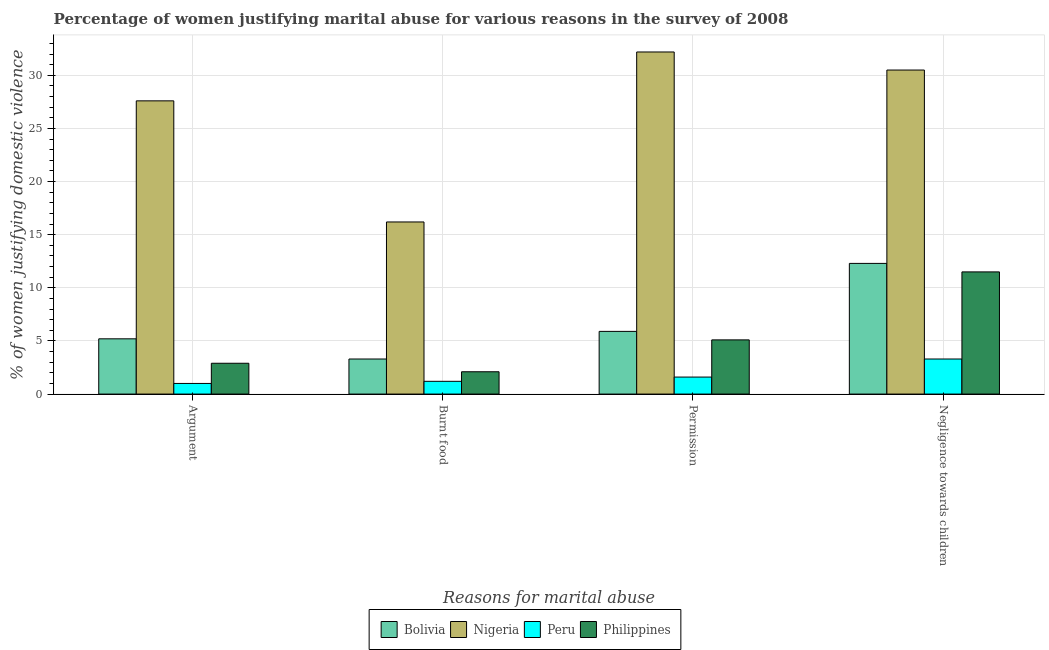How many different coloured bars are there?
Provide a succinct answer. 4. Are the number of bars on each tick of the X-axis equal?
Provide a succinct answer. Yes. How many bars are there on the 3rd tick from the left?
Provide a short and direct response. 4. How many bars are there on the 3rd tick from the right?
Provide a short and direct response. 4. What is the label of the 2nd group of bars from the left?
Offer a terse response. Burnt food. What is the percentage of women justifying abuse for showing negligence towards children in Bolivia?
Keep it short and to the point. 12.3. Across all countries, what is the maximum percentage of women justifying abuse for showing negligence towards children?
Your answer should be very brief. 30.5. In which country was the percentage of women justifying abuse in the case of an argument maximum?
Offer a terse response. Nigeria. What is the total percentage of women justifying abuse in the case of an argument in the graph?
Your response must be concise. 36.7. What is the difference between the percentage of women justifying abuse in the case of an argument in Bolivia and that in Peru?
Give a very brief answer. 4.2. What is the difference between the percentage of women justifying abuse for showing negligence towards children in Peru and the percentage of women justifying abuse for burning food in Nigeria?
Offer a very short reply. -12.9. What is the average percentage of women justifying abuse for burning food per country?
Keep it short and to the point. 5.7. What is the difference between the percentage of women justifying abuse for showing negligence towards children and percentage of women justifying abuse in the case of an argument in Bolivia?
Offer a terse response. 7.1. In how many countries, is the percentage of women justifying abuse for showing negligence towards children greater than 31 %?
Offer a terse response. 0. What is the ratio of the percentage of women justifying abuse for going without permission in Nigeria to that in Bolivia?
Your response must be concise. 5.46. Is the percentage of women justifying abuse in the case of an argument in Peru less than that in Bolivia?
Keep it short and to the point. Yes. Is the difference between the percentage of women justifying abuse for showing negligence towards children in Nigeria and Peru greater than the difference between the percentage of women justifying abuse in the case of an argument in Nigeria and Peru?
Provide a short and direct response. Yes. What is the difference between the highest and the lowest percentage of women justifying abuse for going without permission?
Your answer should be compact. 30.6. In how many countries, is the percentage of women justifying abuse for showing negligence towards children greater than the average percentage of women justifying abuse for showing negligence towards children taken over all countries?
Keep it short and to the point. 1. What does the 4th bar from the left in Argument represents?
Provide a short and direct response. Philippines. What does the 4th bar from the right in Permission represents?
Give a very brief answer. Bolivia. Are all the bars in the graph horizontal?
Your answer should be very brief. No. How many countries are there in the graph?
Provide a short and direct response. 4. Are the values on the major ticks of Y-axis written in scientific E-notation?
Your response must be concise. No. Does the graph contain grids?
Offer a very short reply. Yes. How many legend labels are there?
Your answer should be compact. 4. What is the title of the graph?
Offer a terse response. Percentage of women justifying marital abuse for various reasons in the survey of 2008. What is the label or title of the X-axis?
Make the answer very short. Reasons for marital abuse. What is the label or title of the Y-axis?
Your response must be concise. % of women justifying domestic violence. What is the % of women justifying domestic violence in Bolivia in Argument?
Your answer should be very brief. 5.2. What is the % of women justifying domestic violence in Nigeria in Argument?
Your response must be concise. 27.6. What is the % of women justifying domestic violence in Peru in Argument?
Your response must be concise. 1. What is the % of women justifying domestic violence in Philippines in Argument?
Ensure brevity in your answer.  2.9. What is the % of women justifying domestic violence in Nigeria in Burnt food?
Your answer should be compact. 16.2. What is the % of women justifying domestic violence of Philippines in Burnt food?
Provide a succinct answer. 2.1. What is the % of women justifying domestic violence of Bolivia in Permission?
Your response must be concise. 5.9. What is the % of women justifying domestic violence of Nigeria in Permission?
Ensure brevity in your answer.  32.2. What is the % of women justifying domestic violence in Peru in Permission?
Make the answer very short. 1.6. What is the % of women justifying domestic violence of Nigeria in Negligence towards children?
Offer a terse response. 30.5. What is the % of women justifying domestic violence of Peru in Negligence towards children?
Keep it short and to the point. 3.3. What is the % of women justifying domestic violence of Philippines in Negligence towards children?
Your response must be concise. 11.5. Across all Reasons for marital abuse, what is the maximum % of women justifying domestic violence in Bolivia?
Offer a very short reply. 12.3. Across all Reasons for marital abuse, what is the maximum % of women justifying domestic violence of Nigeria?
Provide a short and direct response. 32.2. Across all Reasons for marital abuse, what is the maximum % of women justifying domestic violence in Peru?
Keep it short and to the point. 3.3. Across all Reasons for marital abuse, what is the minimum % of women justifying domestic violence in Bolivia?
Ensure brevity in your answer.  3.3. Across all Reasons for marital abuse, what is the minimum % of women justifying domestic violence in Peru?
Make the answer very short. 1. What is the total % of women justifying domestic violence in Bolivia in the graph?
Offer a very short reply. 26.7. What is the total % of women justifying domestic violence in Nigeria in the graph?
Make the answer very short. 106.5. What is the total % of women justifying domestic violence in Peru in the graph?
Your answer should be compact. 7.1. What is the total % of women justifying domestic violence in Philippines in the graph?
Your answer should be very brief. 21.6. What is the difference between the % of women justifying domestic violence of Bolivia in Argument and that in Permission?
Offer a terse response. -0.7. What is the difference between the % of women justifying domestic violence in Philippines in Argument and that in Permission?
Your answer should be very brief. -2.2. What is the difference between the % of women justifying domestic violence of Bolivia in Argument and that in Negligence towards children?
Offer a very short reply. -7.1. What is the difference between the % of women justifying domestic violence in Peru in Argument and that in Negligence towards children?
Ensure brevity in your answer.  -2.3. What is the difference between the % of women justifying domestic violence in Philippines in Argument and that in Negligence towards children?
Your answer should be compact. -8.6. What is the difference between the % of women justifying domestic violence of Bolivia in Burnt food and that in Permission?
Your response must be concise. -2.6. What is the difference between the % of women justifying domestic violence in Nigeria in Burnt food and that in Permission?
Your answer should be very brief. -16. What is the difference between the % of women justifying domestic violence of Nigeria in Burnt food and that in Negligence towards children?
Your answer should be very brief. -14.3. What is the difference between the % of women justifying domestic violence in Peru in Burnt food and that in Negligence towards children?
Your answer should be very brief. -2.1. What is the difference between the % of women justifying domestic violence in Philippines in Burnt food and that in Negligence towards children?
Make the answer very short. -9.4. What is the difference between the % of women justifying domestic violence of Bolivia in Permission and that in Negligence towards children?
Offer a terse response. -6.4. What is the difference between the % of women justifying domestic violence in Nigeria in Permission and that in Negligence towards children?
Your answer should be compact. 1.7. What is the difference between the % of women justifying domestic violence in Bolivia in Argument and the % of women justifying domestic violence in Peru in Burnt food?
Give a very brief answer. 4. What is the difference between the % of women justifying domestic violence of Bolivia in Argument and the % of women justifying domestic violence of Philippines in Burnt food?
Provide a short and direct response. 3.1. What is the difference between the % of women justifying domestic violence in Nigeria in Argument and the % of women justifying domestic violence in Peru in Burnt food?
Your answer should be compact. 26.4. What is the difference between the % of women justifying domestic violence in Peru in Argument and the % of women justifying domestic violence in Philippines in Burnt food?
Offer a very short reply. -1.1. What is the difference between the % of women justifying domestic violence of Bolivia in Argument and the % of women justifying domestic violence of Nigeria in Permission?
Make the answer very short. -27. What is the difference between the % of women justifying domestic violence in Bolivia in Argument and the % of women justifying domestic violence in Peru in Permission?
Your answer should be very brief. 3.6. What is the difference between the % of women justifying domestic violence of Bolivia in Argument and the % of women justifying domestic violence of Philippines in Permission?
Make the answer very short. 0.1. What is the difference between the % of women justifying domestic violence of Nigeria in Argument and the % of women justifying domestic violence of Peru in Permission?
Give a very brief answer. 26. What is the difference between the % of women justifying domestic violence in Bolivia in Argument and the % of women justifying domestic violence in Nigeria in Negligence towards children?
Your answer should be very brief. -25.3. What is the difference between the % of women justifying domestic violence in Nigeria in Argument and the % of women justifying domestic violence in Peru in Negligence towards children?
Provide a succinct answer. 24.3. What is the difference between the % of women justifying domestic violence in Nigeria in Argument and the % of women justifying domestic violence in Philippines in Negligence towards children?
Offer a very short reply. 16.1. What is the difference between the % of women justifying domestic violence of Bolivia in Burnt food and the % of women justifying domestic violence of Nigeria in Permission?
Keep it short and to the point. -28.9. What is the difference between the % of women justifying domestic violence in Bolivia in Burnt food and the % of women justifying domestic violence in Peru in Permission?
Provide a short and direct response. 1.7. What is the difference between the % of women justifying domestic violence of Nigeria in Burnt food and the % of women justifying domestic violence of Philippines in Permission?
Make the answer very short. 11.1. What is the difference between the % of women justifying domestic violence in Bolivia in Burnt food and the % of women justifying domestic violence in Nigeria in Negligence towards children?
Provide a succinct answer. -27.2. What is the difference between the % of women justifying domestic violence of Bolivia in Burnt food and the % of women justifying domestic violence of Peru in Negligence towards children?
Provide a short and direct response. 0. What is the difference between the % of women justifying domestic violence of Bolivia in Permission and the % of women justifying domestic violence of Nigeria in Negligence towards children?
Offer a terse response. -24.6. What is the difference between the % of women justifying domestic violence of Bolivia in Permission and the % of women justifying domestic violence of Philippines in Negligence towards children?
Ensure brevity in your answer.  -5.6. What is the difference between the % of women justifying domestic violence in Nigeria in Permission and the % of women justifying domestic violence in Peru in Negligence towards children?
Keep it short and to the point. 28.9. What is the difference between the % of women justifying domestic violence of Nigeria in Permission and the % of women justifying domestic violence of Philippines in Negligence towards children?
Provide a short and direct response. 20.7. What is the average % of women justifying domestic violence of Bolivia per Reasons for marital abuse?
Your answer should be very brief. 6.67. What is the average % of women justifying domestic violence in Nigeria per Reasons for marital abuse?
Your answer should be compact. 26.62. What is the average % of women justifying domestic violence in Peru per Reasons for marital abuse?
Offer a terse response. 1.77. What is the average % of women justifying domestic violence of Philippines per Reasons for marital abuse?
Ensure brevity in your answer.  5.4. What is the difference between the % of women justifying domestic violence in Bolivia and % of women justifying domestic violence in Nigeria in Argument?
Provide a short and direct response. -22.4. What is the difference between the % of women justifying domestic violence of Bolivia and % of women justifying domestic violence of Philippines in Argument?
Your response must be concise. 2.3. What is the difference between the % of women justifying domestic violence of Nigeria and % of women justifying domestic violence of Peru in Argument?
Your response must be concise. 26.6. What is the difference between the % of women justifying domestic violence in Nigeria and % of women justifying domestic violence in Philippines in Argument?
Your answer should be compact. 24.7. What is the difference between the % of women justifying domestic violence in Peru and % of women justifying domestic violence in Philippines in Argument?
Offer a very short reply. -1.9. What is the difference between the % of women justifying domestic violence in Bolivia and % of women justifying domestic violence in Peru in Burnt food?
Keep it short and to the point. 2.1. What is the difference between the % of women justifying domestic violence of Bolivia and % of women justifying domestic violence of Philippines in Burnt food?
Your answer should be very brief. 1.2. What is the difference between the % of women justifying domestic violence of Bolivia and % of women justifying domestic violence of Nigeria in Permission?
Make the answer very short. -26.3. What is the difference between the % of women justifying domestic violence in Bolivia and % of women justifying domestic violence in Philippines in Permission?
Provide a short and direct response. 0.8. What is the difference between the % of women justifying domestic violence in Nigeria and % of women justifying domestic violence in Peru in Permission?
Your response must be concise. 30.6. What is the difference between the % of women justifying domestic violence in Nigeria and % of women justifying domestic violence in Philippines in Permission?
Ensure brevity in your answer.  27.1. What is the difference between the % of women justifying domestic violence of Peru and % of women justifying domestic violence of Philippines in Permission?
Keep it short and to the point. -3.5. What is the difference between the % of women justifying domestic violence of Bolivia and % of women justifying domestic violence of Nigeria in Negligence towards children?
Offer a very short reply. -18.2. What is the difference between the % of women justifying domestic violence of Nigeria and % of women justifying domestic violence of Peru in Negligence towards children?
Make the answer very short. 27.2. What is the ratio of the % of women justifying domestic violence in Bolivia in Argument to that in Burnt food?
Provide a succinct answer. 1.58. What is the ratio of the % of women justifying domestic violence of Nigeria in Argument to that in Burnt food?
Your answer should be compact. 1.7. What is the ratio of the % of women justifying domestic violence of Peru in Argument to that in Burnt food?
Your answer should be very brief. 0.83. What is the ratio of the % of women justifying domestic violence in Philippines in Argument to that in Burnt food?
Provide a short and direct response. 1.38. What is the ratio of the % of women justifying domestic violence of Bolivia in Argument to that in Permission?
Your answer should be very brief. 0.88. What is the ratio of the % of women justifying domestic violence in Peru in Argument to that in Permission?
Provide a short and direct response. 0.62. What is the ratio of the % of women justifying domestic violence of Philippines in Argument to that in Permission?
Keep it short and to the point. 0.57. What is the ratio of the % of women justifying domestic violence of Bolivia in Argument to that in Negligence towards children?
Your response must be concise. 0.42. What is the ratio of the % of women justifying domestic violence of Nigeria in Argument to that in Negligence towards children?
Offer a very short reply. 0.9. What is the ratio of the % of women justifying domestic violence in Peru in Argument to that in Negligence towards children?
Your answer should be compact. 0.3. What is the ratio of the % of women justifying domestic violence in Philippines in Argument to that in Negligence towards children?
Provide a succinct answer. 0.25. What is the ratio of the % of women justifying domestic violence in Bolivia in Burnt food to that in Permission?
Your answer should be very brief. 0.56. What is the ratio of the % of women justifying domestic violence in Nigeria in Burnt food to that in Permission?
Offer a terse response. 0.5. What is the ratio of the % of women justifying domestic violence of Peru in Burnt food to that in Permission?
Give a very brief answer. 0.75. What is the ratio of the % of women justifying domestic violence in Philippines in Burnt food to that in Permission?
Keep it short and to the point. 0.41. What is the ratio of the % of women justifying domestic violence in Bolivia in Burnt food to that in Negligence towards children?
Your answer should be compact. 0.27. What is the ratio of the % of women justifying domestic violence in Nigeria in Burnt food to that in Negligence towards children?
Provide a short and direct response. 0.53. What is the ratio of the % of women justifying domestic violence in Peru in Burnt food to that in Negligence towards children?
Ensure brevity in your answer.  0.36. What is the ratio of the % of women justifying domestic violence in Philippines in Burnt food to that in Negligence towards children?
Provide a succinct answer. 0.18. What is the ratio of the % of women justifying domestic violence in Bolivia in Permission to that in Negligence towards children?
Offer a very short reply. 0.48. What is the ratio of the % of women justifying domestic violence of Nigeria in Permission to that in Negligence towards children?
Your answer should be very brief. 1.06. What is the ratio of the % of women justifying domestic violence of Peru in Permission to that in Negligence towards children?
Give a very brief answer. 0.48. What is the ratio of the % of women justifying domestic violence of Philippines in Permission to that in Negligence towards children?
Provide a succinct answer. 0.44. What is the difference between the highest and the second highest % of women justifying domestic violence of Nigeria?
Provide a succinct answer. 1.7. What is the difference between the highest and the second highest % of women justifying domestic violence of Peru?
Offer a terse response. 1.7. What is the difference between the highest and the lowest % of women justifying domestic violence of Bolivia?
Your answer should be very brief. 9. 